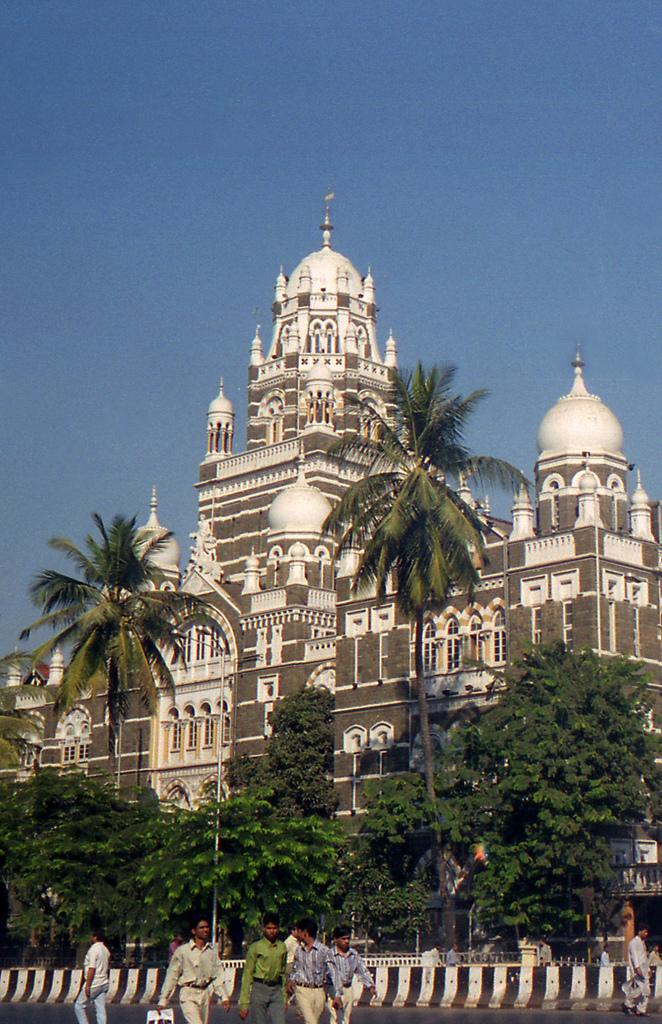What are the people in the image doing? The people in the image are walking on a road. What can be seen in the background of the image? There are trees and a palace in the background of the image. What is visible in the sky in the image? The sky is visible in the background of the image. What type of mailbox can be seen on the palace in the image? There is no mailbox visible on the palace in the image. What type of apparel are the people wearing that indicates it is hot outside? The image does not provide information about the apparel the people are wearing or the temperature outside. 